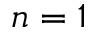<formula> <loc_0><loc_0><loc_500><loc_500>n = 1</formula> 